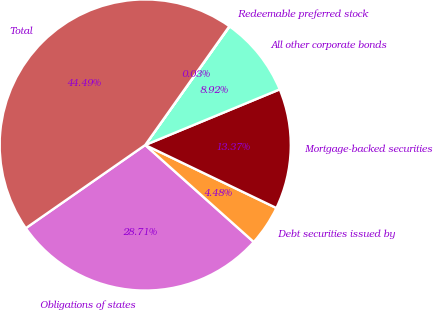Convert chart to OTSL. <chart><loc_0><loc_0><loc_500><loc_500><pie_chart><fcel>Obligations of states<fcel>Debt securities issued by<fcel>Mortgage-backed securities<fcel>All other corporate bonds<fcel>Redeemable preferred stock<fcel>Total<nl><fcel>28.71%<fcel>4.48%<fcel>13.37%<fcel>8.92%<fcel>0.03%<fcel>44.49%<nl></chart> 